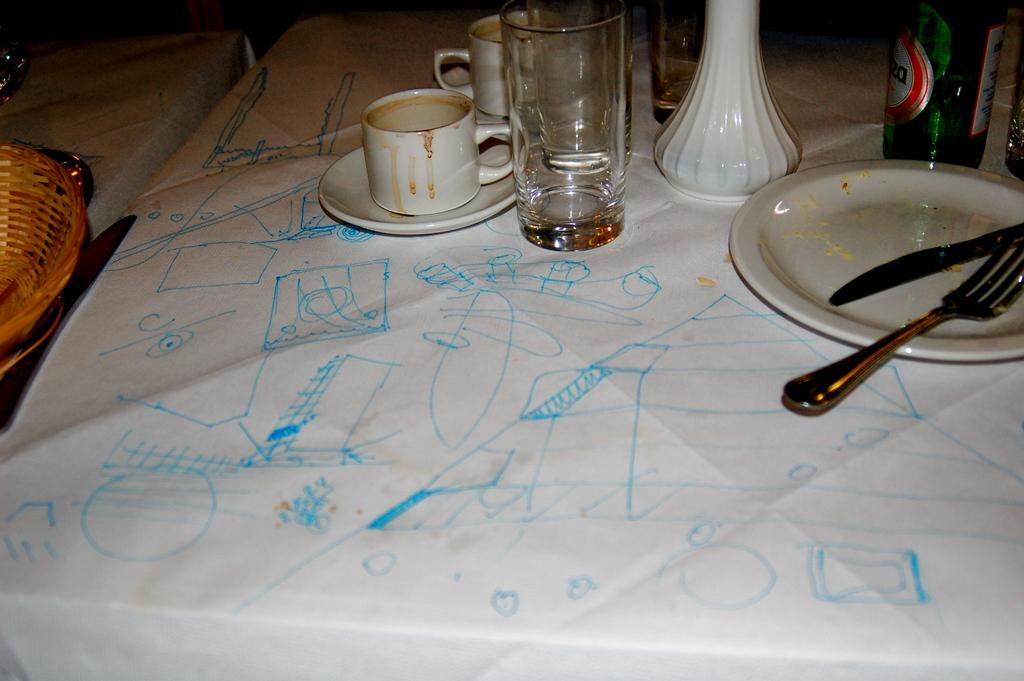What piece of furniture is present in the image? There is a table in the image. What items can be seen on the table? There is a glass, a bottle, a plate, a cup, a saucer, a fork, and a spoon on the table. Is there any other table visible in the image? Yes, there is another table visible in the background. How many dogs are sitting on the chairs around the table in the image? There are no dogs present in the image. What type of trees can be seen through the window in the image? There is no window or trees visible in the image. 